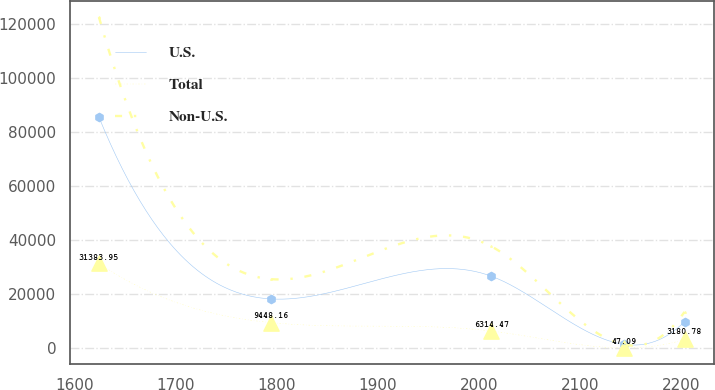Convert chart. <chart><loc_0><loc_0><loc_500><loc_500><line_chart><ecel><fcel>U.S.<fcel>Total<fcel>Non-U.S.<nl><fcel>1623.95<fcel>85598<fcel>31384<fcel>122675<nl><fcel>1793.88<fcel>18210<fcel>9448.16<fcel>25544.2<nl><fcel>2012.17<fcel>26633.5<fcel>6314.47<fcel>37685.6<nl><fcel>2143.48<fcel>1362.96<fcel>47.09<fcel>1261.5<nl><fcel>2203.31<fcel>9786.46<fcel>3180.78<fcel>13402.9<nl></chart> 